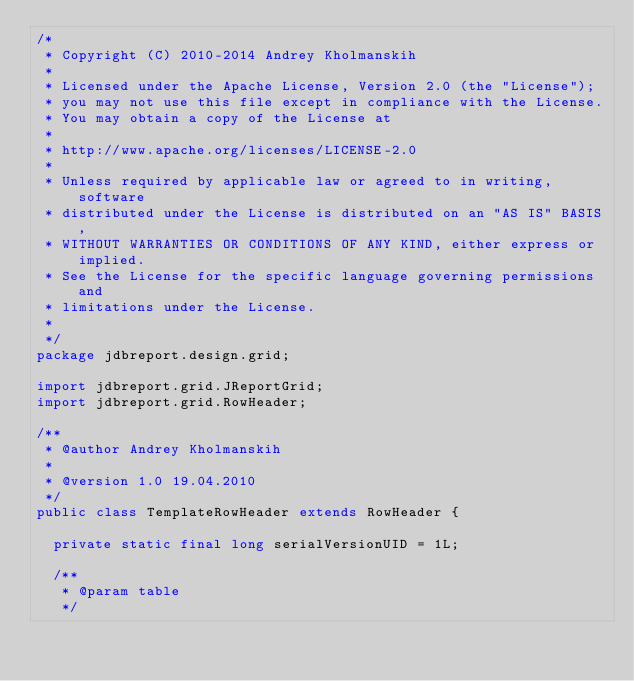<code> <loc_0><loc_0><loc_500><loc_500><_Java_>/*
 * Copyright (C) 2010-2014 Andrey Kholmanskih
 *
 * Licensed under the Apache License, Version 2.0 (the "License");
 * you may not use this file except in compliance with the License.
 * You may obtain a copy of the License at
 *
 * http://www.apache.org/licenses/LICENSE-2.0
 *
 * Unless required by applicable law or agreed to in writing, software
 * distributed under the License is distributed on an "AS IS" BASIS,
 * WITHOUT WARRANTIES OR CONDITIONS OF ANY KIND, either express or implied.
 * See the License for the specific language governing permissions and
 * limitations under the License.
 *
 */
package jdbreport.design.grid;

import jdbreport.grid.JReportGrid;
import jdbreport.grid.RowHeader;

/**
 * @author Andrey Kholmanskih
 *
 * @version 1.0 19.04.2010
 */
public class TemplateRowHeader extends RowHeader {

	private static final long serialVersionUID = 1L;

	/**
	 * @param table
	 */</code> 